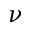<formula> <loc_0><loc_0><loc_500><loc_500>\nu</formula> 